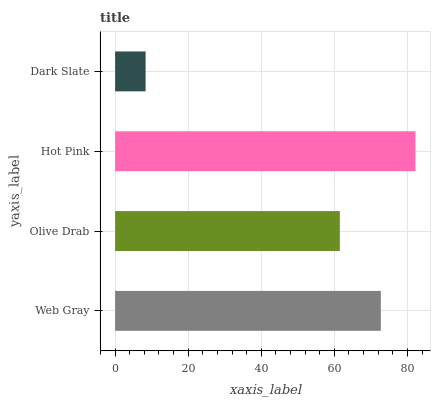Is Dark Slate the minimum?
Answer yes or no. Yes. Is Hot Pink the maximum?
Answer yes or no. Yes. Is Olive Drab the minimum?
Answer yes or no. No. Is Olive Drab the maximum?
Answer yes or no. No. Is Web Gray greater than Olive Drab?
Answer yes or no. Yes. Is Olive Drab less than Web Gray?
Answer yes or no. Yes. Is Olive Drab greater than Web Gray?
Answer yes or no. No. Is Web Gray less than Olive Drab?
Answer yes or no. No. Is Web Gray the high median?
Answer yes or no. Yes. Is Olive Drab the low median?
Answer yes or no. Yes. Is Hot Pink the high median?
Answer yes or no. No. Is Hot Pink the low median?
Answer yes or no. No. 